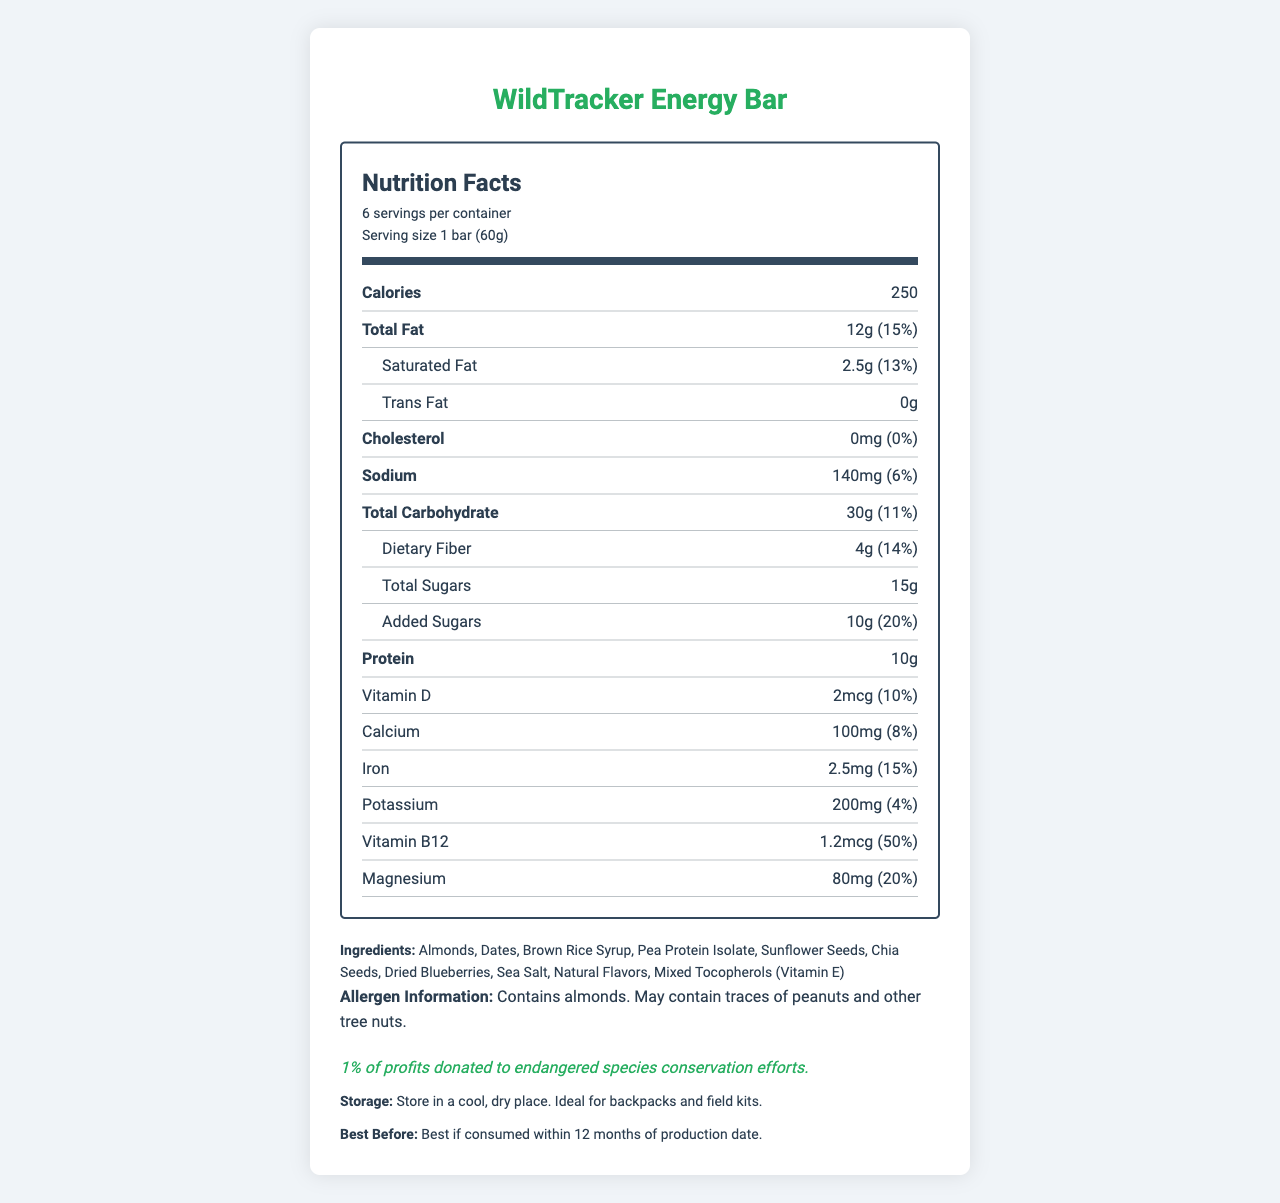how many servings are in the container? The document states that there are 6 servings per container.
Answer: 6 what is the total fat content per serving? The document lists the total fat content as 12g per serving.
Answer: 12g how much protein does each bar contain? The document specifies that each bar contains 10g of protein.
Answer: 10g what vitamins are included in the WildTracker Energy Bar? The document mentions the amounts and daily values of Vitamin D and Vitamin B12.
Answer: Vitamin D and Vitamin B12 how much added sugars are in one serving? The document mentions that each serving contains 10g of added sugars.
Answer: 10g does the WildTracker Energy Bar contain any cholesterol? The document shows that the cholesterol content is 0mg and 0% of the daily value.
Answer: No what is the expiration date guideline for this product? The document states the product is best if consumed within 12 months of production date.
Answer: Best if consumed within 12 months of production date which ingredient is not listed in the WildTracker Energy Bar? A. Almonds B. Milk Protein Isolate C. Chia Seeds D. Dates Milk Protein Isolate is not listed among the ingredients in the document.
Answer: B. Milk Protein Isolate what is the daily value percentage of magnesium in the bar? A. 10% B. 15% C. 20% D. 25% The document states that the magnesium content is 80mg, which is 20% of the daily value.
Answer: C. 20% is the product suitable for someone with a tree nut allergy? The document states that the product contains almonds and may contain traces of peanuts and other tree nuts.
Answer: No summarize the information on the WildTracker Energy Bar nutrition label. This summary covers the key aspects, including nutritional content, ingredients, special notes, and usage instructions.
Answer: The WildTracker Energy Bar is designed for long wildlife observation treks. It has 250 calories per serving and contains nutrients like 12g of total fat, 10g of protein, and various vitamins and minerals. The ingredients include almonds, dates, and chia seeds, and it offers a 1% profit donation to endangered species conservation efforts. It has allergen information and storage instructions, ideal for field kits. what is the percentage of the daily value of potassium in one bar? The document lists the potassium content as 200mg, which is 4% of the daily value.
Answer: 4% does the product label mention if the bar is gluten-free? The document does not specify whether the product is gluten-free.
Answer: Not enough information how many grams of dietary fiber are in one serving of the WildTracker Energy Bar? The document indicates that each serving of the bar contains 4g of dietary fiber.
Answer: 4g what are the storage instructions for the WildTracker Energy Bar? The document provides specific storage instructions, suggesting a cool, dry place and highlighting its suitability for field kits.
Answer: Store in a cool, dry place. Ideal for backpacks and field kits. 